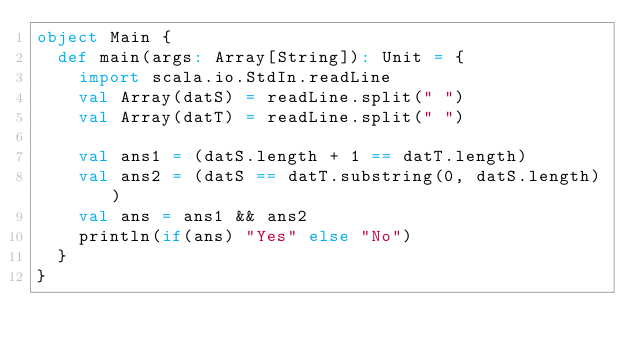Convert code to text. <code><loc_0><loc_0><loc_500><loc_500><_Scala_>object Main {
  def main(args: Array[String]): Unit = {
    import scala.io.StdIn.readLine
    val Array(datS) = readLine.split(" ")
    val Array(datT) = readLine.split(" ")

    val ans1 = (datS.length + 1 == datT.length)
    val ans2 = (datS == datT.substring(0, datS.length))
    val ans = ans1 && ans2
    println(if(ans) "Yes" else "No")
  }
}
</code> 